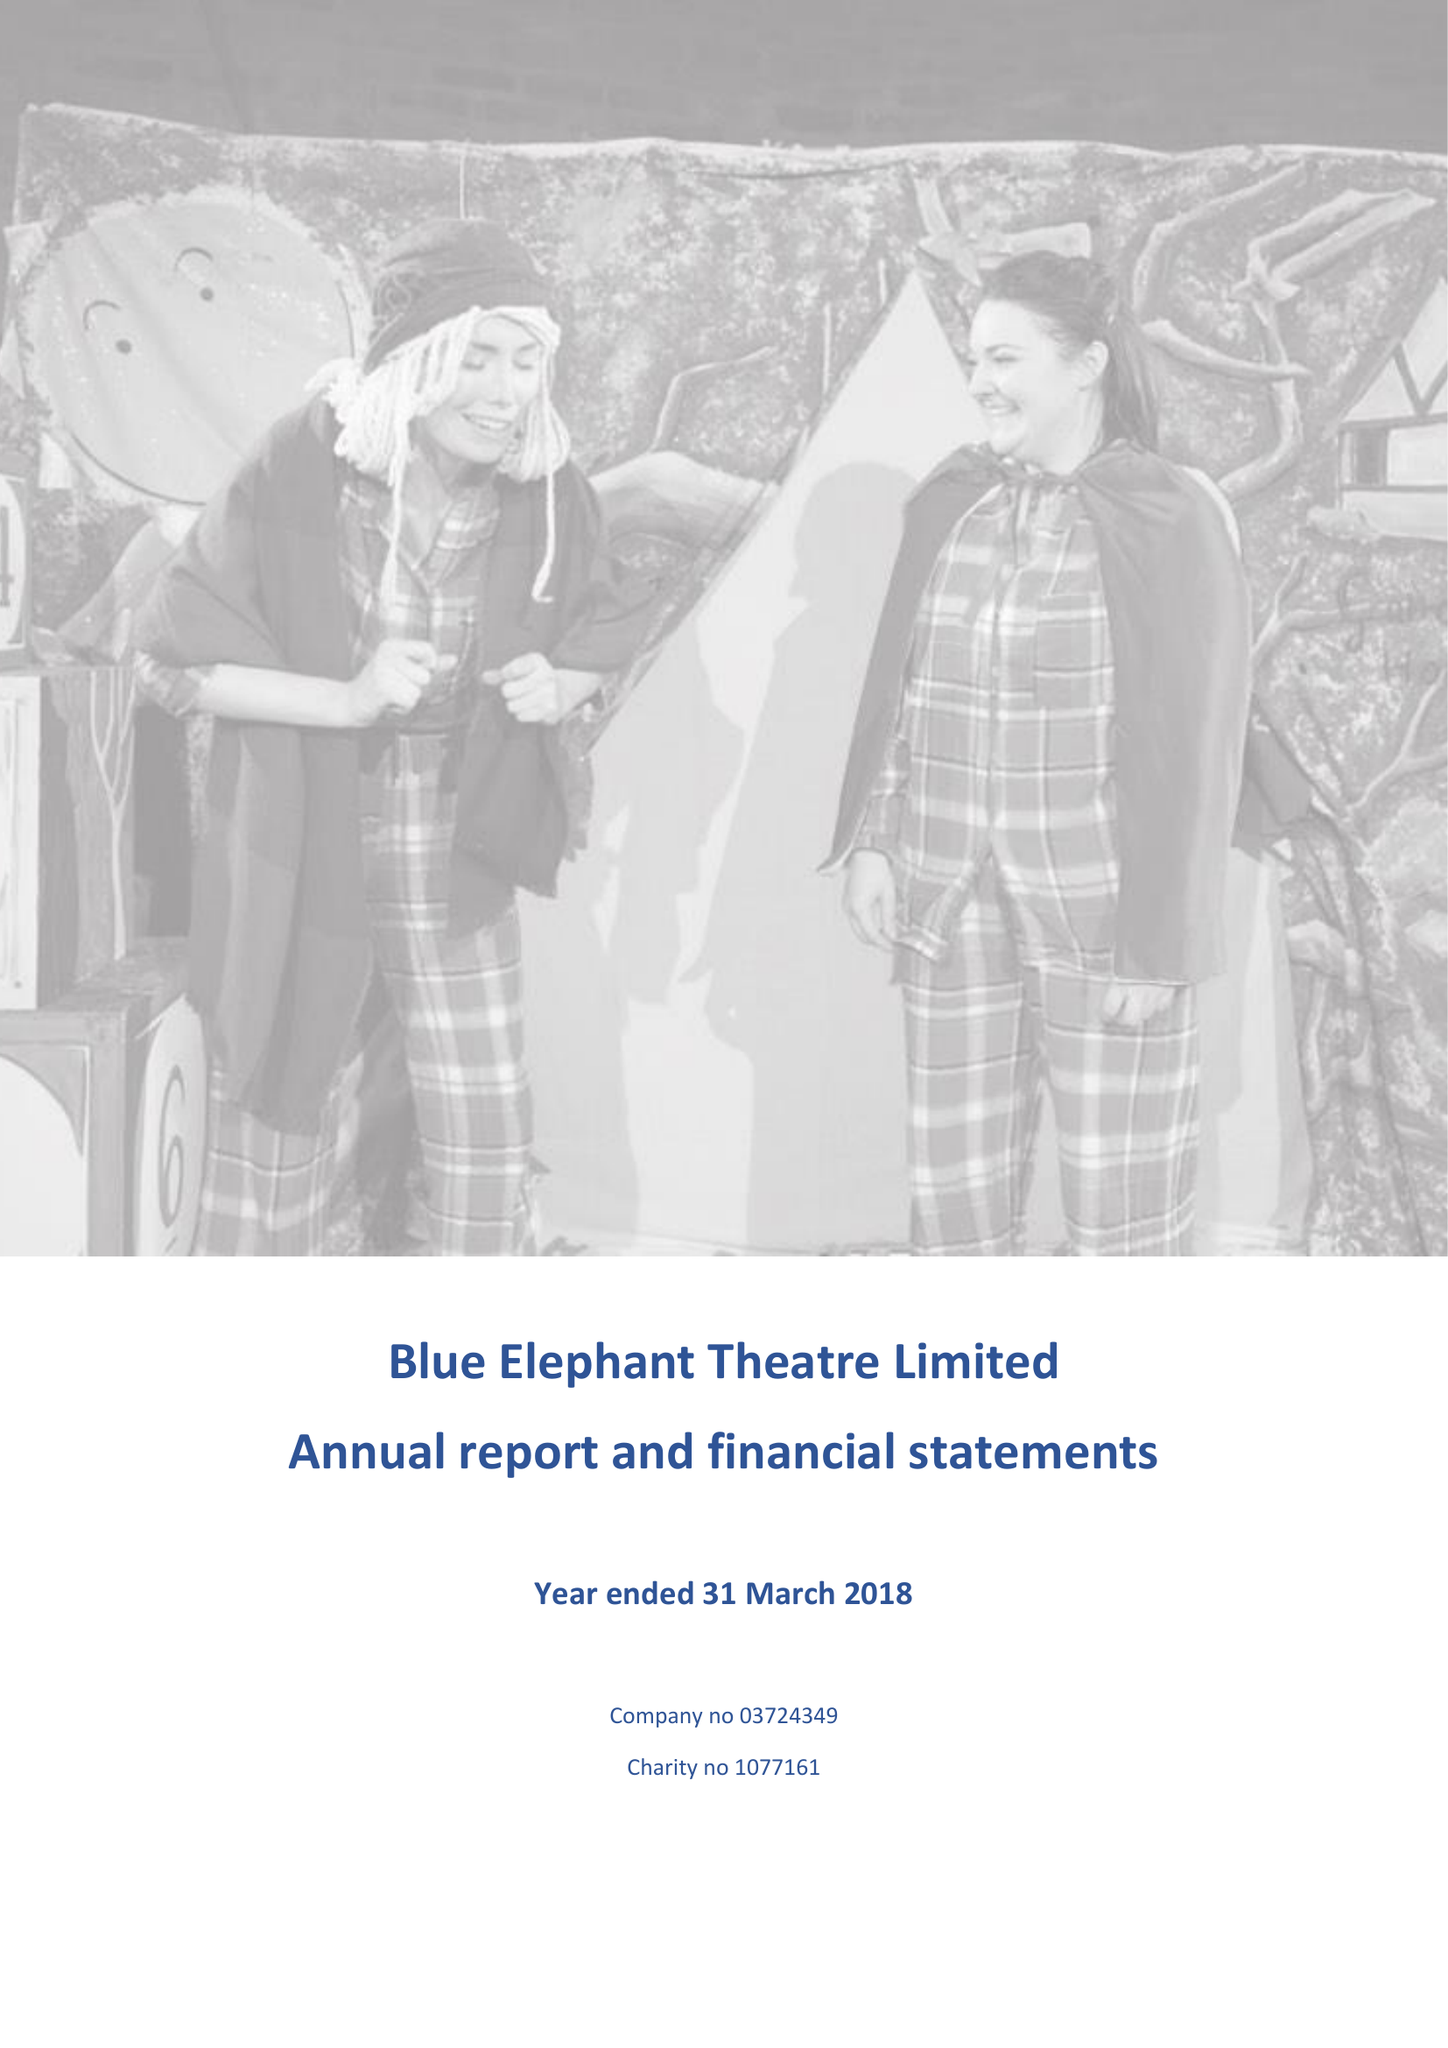What is the value for the income_annually_in_british_pounds?
Answer the question using a single word or phrase. 185828.00 